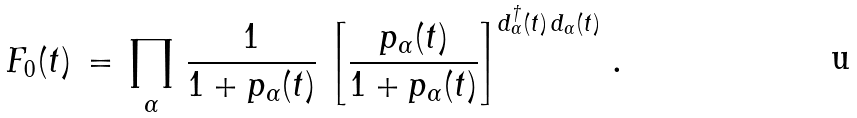Convert formula to latex. <formula><loc_0><loc_0><loc_500><loc_500>F _ { 0 } ( t ) \, = \, \prod _ { \alpha } \, \frac { 1 } { 1 + p _ { \alpha } ( t ) } \, \left [ \frac { p _ { \alpha } ( t ) } { 1 + p _ { \alpha } ( t ) } \right ] ^ { d ^ { \dag } _ { \alpha } ( t ) \, d _ { \alpha } ( t ) } \, .</formula> 